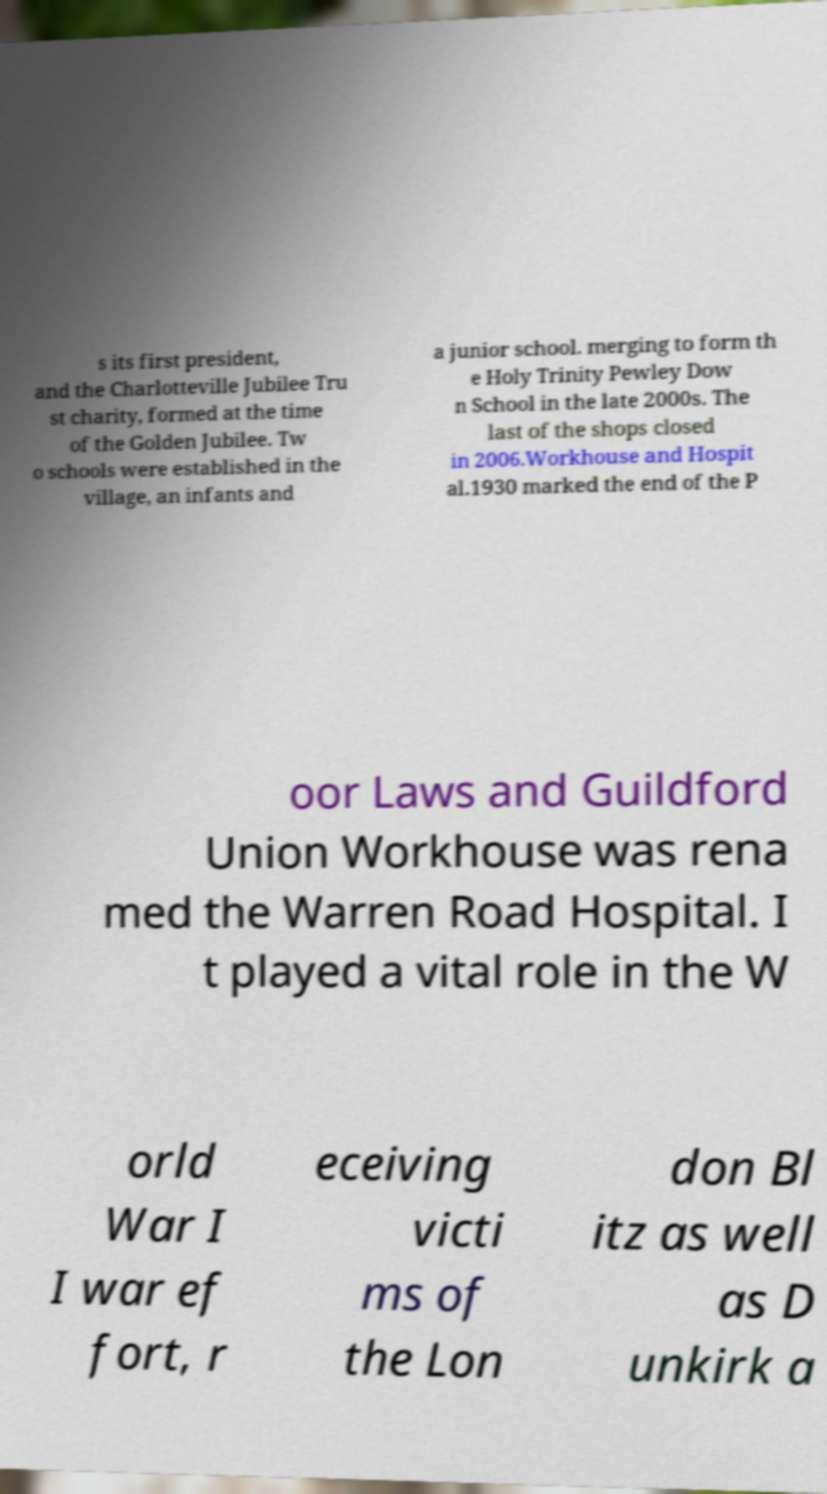Could you extract and type out the text from this image? s its first president, and the Charlotteville Jubilee Tru st charity, formed at the time of the Golden Jubilee. Tw o schools were established in the village, an infants and a junior school. merging to form th e Holy Trinity Pewley Dow n School in the late 2000s. The last of the shops closed in 2006.Workhouse and Hospit al.1930 marked the end of the P oor Laws and Guildford Union Workhouse was rena med the Warren Road Hospital. I t played a vital role in the W orld War I I war ef fort, r eceiving victi ms of the Lon don Bl itz as well as D unkirk a 